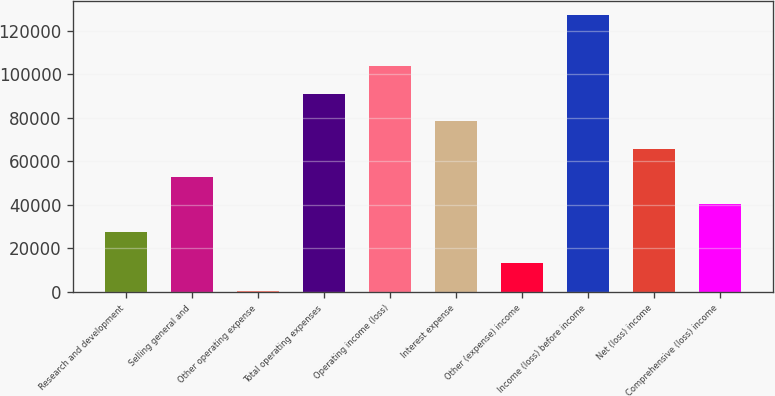Convert chart. <chart><loc_0><loc_0><loc_500><loc_500><bar_chart><fcel>Research and development<fcel>Selling general and<fcel>Other operating expense<fcel>Total operating expenses<fcel>Operating income (loss)<fcel>Interest expense<fcel>Other (expense) income<fcel>Income (loss) before income<fcel>Net (loss) income<fcel>Comprehensive (loss) income<nl><fcel>27688<fcel>53014.4<fcel>588<fcel>91004<fcel>103667<fcel>78340.8<fcel>13251.2<fcel>127220<fcel>65677.6<fcel>40351.2<nl></chart> 